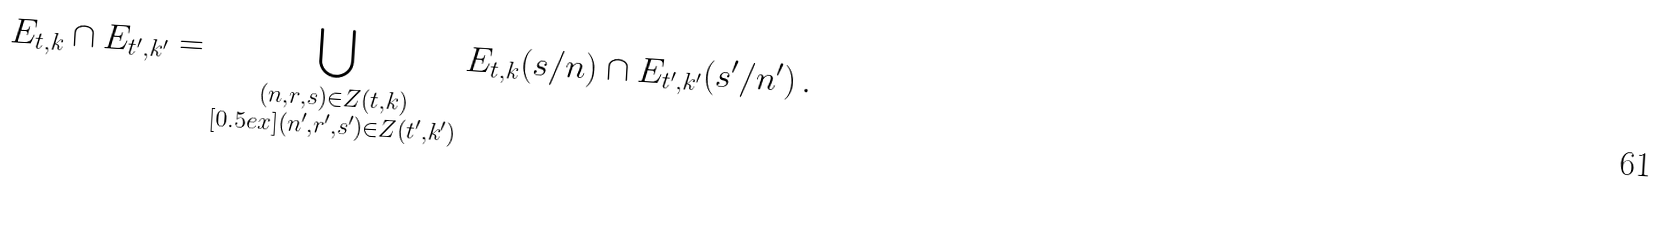Convert formula to latex. <formula><loc_0><loc_0><loc_500><loc_500>E _ { t , k } \cap E _ { t ^ { \prime } , k ^ { \prime } } = \bigcup _ { \substack { ( n , r , s ) \in Z ( t , k ) \\ [ 0 . 5 e x ] ( n ^ { \prime } , r ^ { \prime } , s ^ { \prime } ) \in Z ( t ^ { \prime } , k ^ { \prime } ) } } E _ { t , k } ( s / n ) \cap E _ { t ^ { \prime } , k ^ { \prime } } ( s ^ { \prime } / n ^ { \prime } ) \, .</formula> 